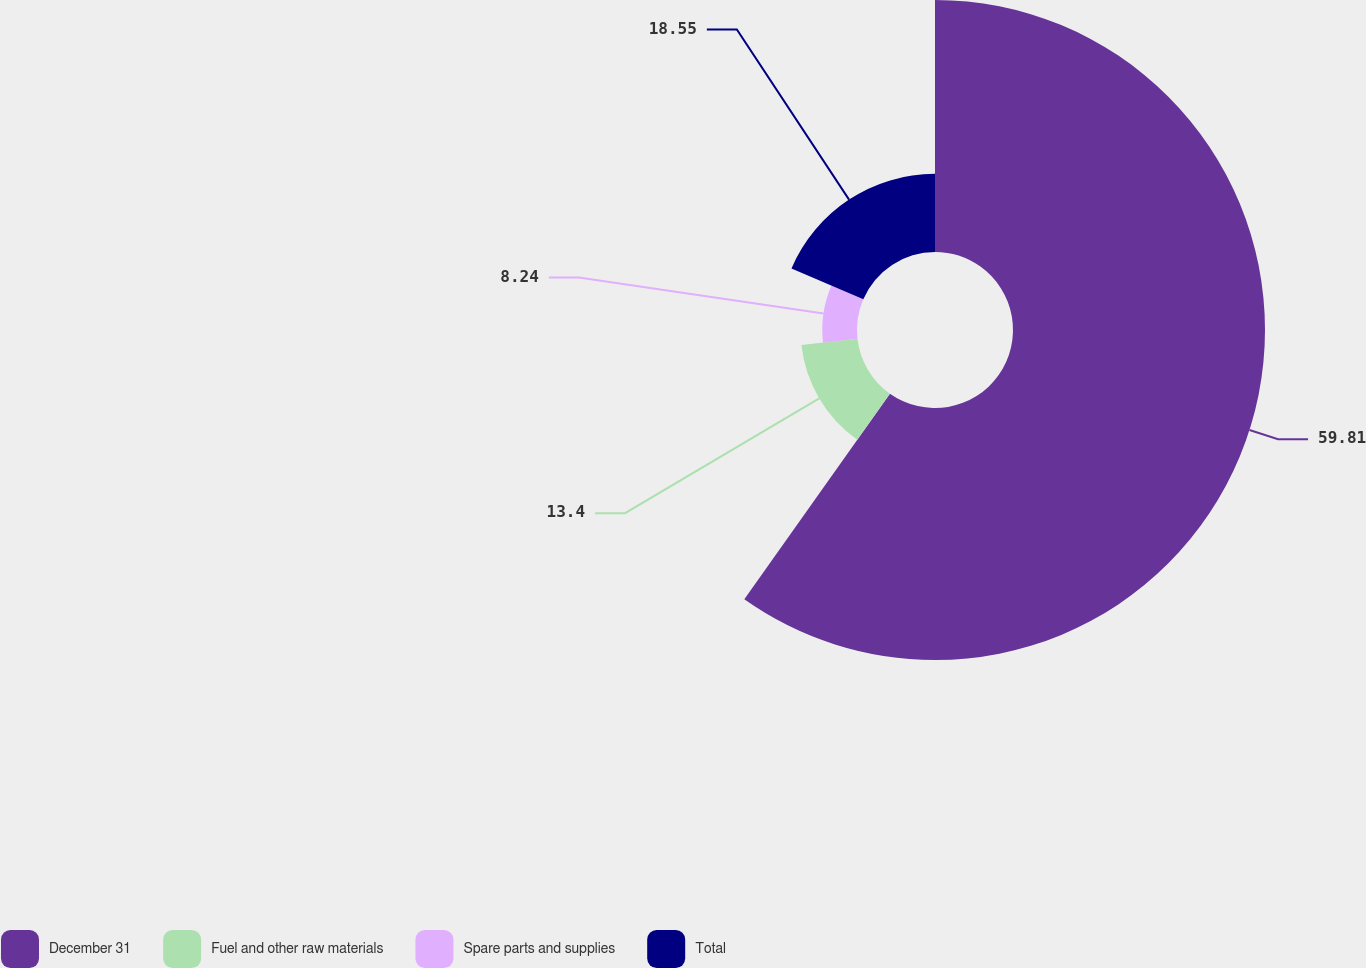<chart> <loc_0><loc_0><loc_500><loc_500><pie_chart><fcel>December 31<fcel>Fuel and other raw materials<fcel>Spare parts and supplies<fcel>Total<nl><fcel>59.8%<fcel>13.4%<fcel>8.24%<fcel>18.55%<nl></chart> 